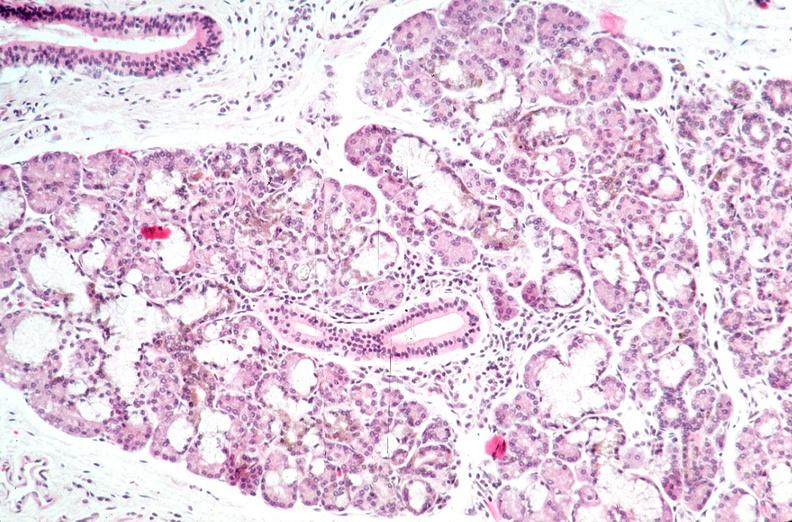does this protocol show pancreas, hemochromatosis?
Answer the question using a single word or phrase. No 